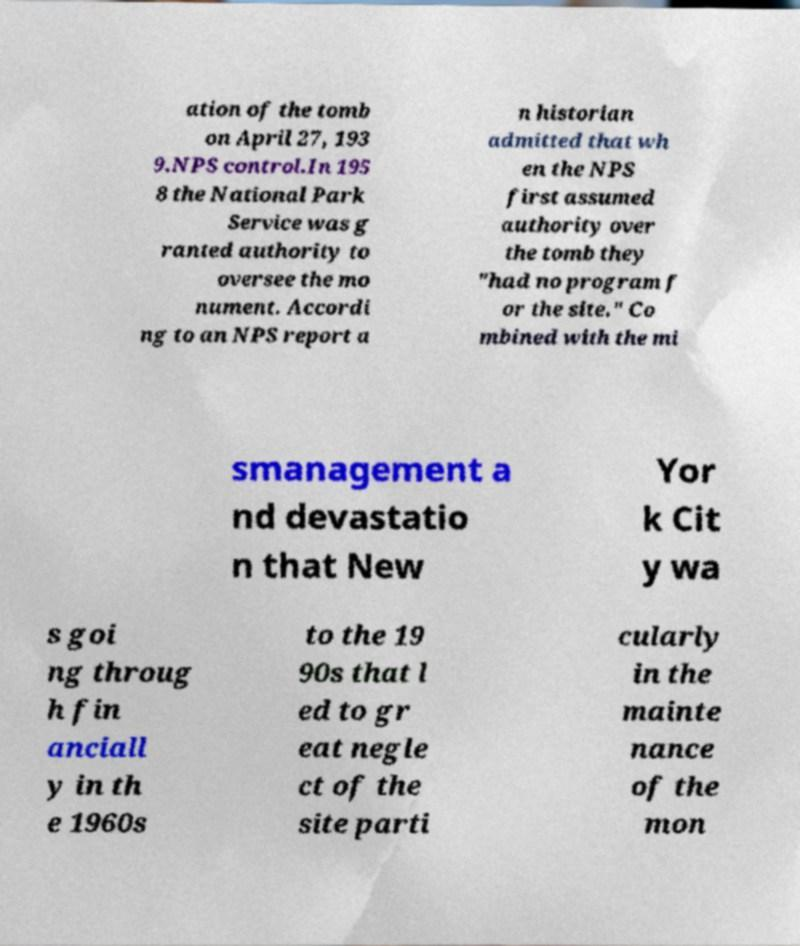Can you read and provide the text displayed in the image?This photo seems to have some interesting text. Can you extract and type it out for me? ation of the tomb on April 27, 193 9.NPS control.In 195 8 the National Park Service was g ranted authority to oversee the mo nument. Accordi ng to an NPS report a n historian admitted that wh en the NPS first assumed authority over the tomb they "had no program f or the site." Co mbined with the mi smanagement a nd devastatio n that New Yor k Cit y wa s goi ng throug h fin anciall y in th e 1960s to the 19 90s that l ed to gr eat negle ct of the site parti cularly in the mainte nance of the mon 